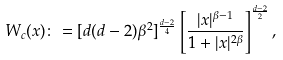Convert formula to latex. <formula><loc_0><loc_0><loc_500><loc_500>W _ { c } ( x ) \colon = [ d ( d - 2 ) \beta ^ { 2 } ] ^ { \frac { d - 2 } { 4 } } \left [ \frac { | x | ^ { \beta - 1 } } { 1 + | x | ^ { 2 \beta } } \right ] ^ { \frac { d - 2 } { 2 } } ,</formula> 